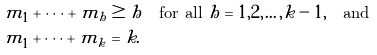Convert formula to latex. <formula><loc_0><loc_0><loc_500><loc_500>m _ { 1 } + \dots + m _ { h } & \geq h \quad \text {for all } h = 1 , 2 , \dots , k - 1 , \quad \text {and} \\ m _ { 1 } + \dots + m _ { k } & = k .</formula> 